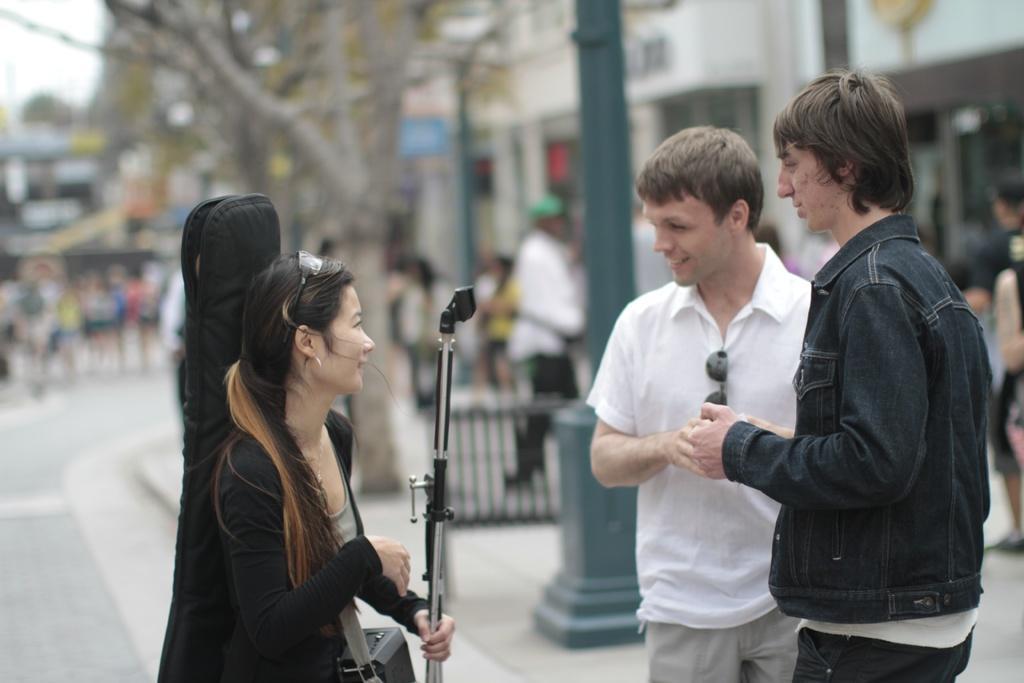In one or two sentences, can you explain what this image depicts? In this picture there are two people standing and there is a woman standing and holding the object in the foreground. At the back there are buildings and trees and there are street lights on the footpath and there are group of people walking on the footpath and there are group of people walking on the road and there is text on the building. At the top there is sky. At the bottom there is a road. 